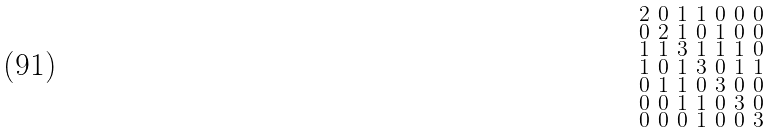<formula> <loc_0><loc_0><loc_500><loc_500>\begin{smallmatrix} 2 & 0 & 1 & 1 & 0 & 0 & 0 \\ 0 & 2 & 1 & 0 & 1 & 0 & 0 \\ 1 & 1 & 3 & 1 & 1 & 1 & 0 \\ 1 & 0 & 1 & 3 & 0 & 1 & 1 \\ 0 & 1 & 1 & 0 & 3 & 0 & 0 \\ 0 & 0 & 1 & 1 & 0 & 3 & 0 \\ 0 & 0 & 0 & 1 & 0 & 0 & 3 \end{smallmatrix}</formula> 